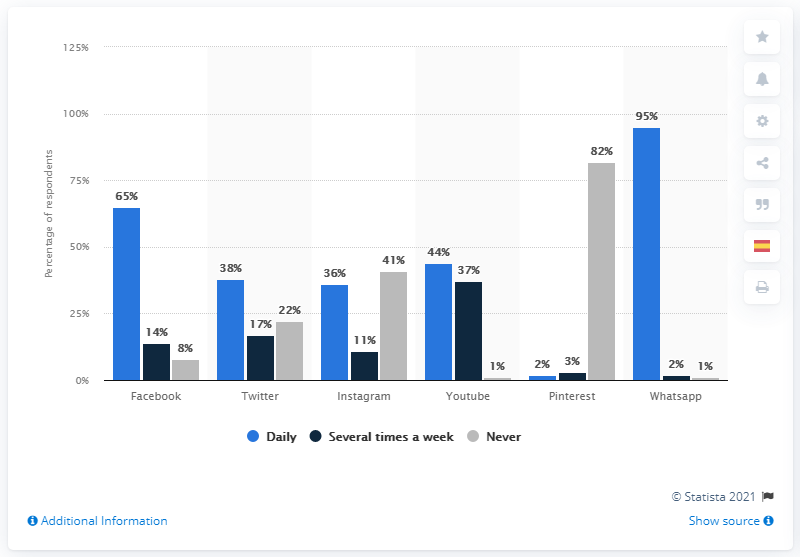Mention a couple of crucial points in this snapshot. Whatsapp was the most widely used social media platform in Spain in 2014. 